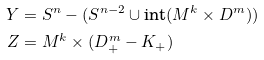Convert formula to latex. <formula><loc_0><loc_0><loc_500><loc_500>Y & = S ^ { n } - ( S ^ { n - 2 } \cup \text {int} ( M ^ { k } \times D ^ { m } ) ) \\ Z & = M ^ { k } \times ( D _ { + } ^ { m } - K _ { + } )</formula> 